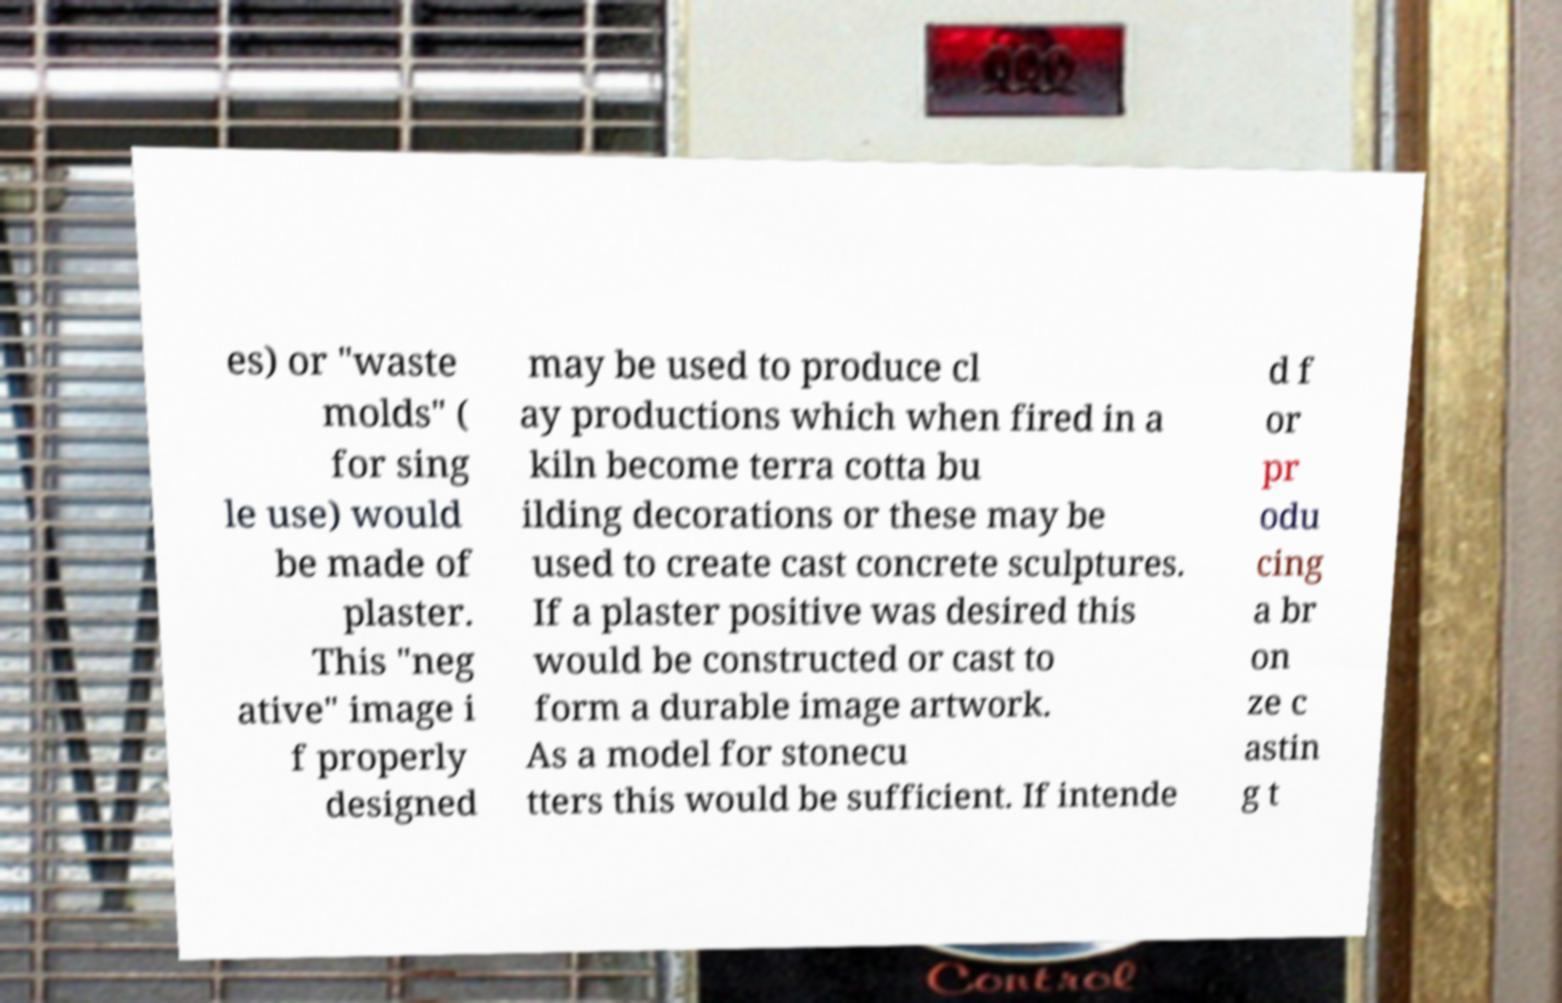What messages or text are displayed in this image? I need them in a readable, typed format. es) or "waste molds" ( for sing le use) would be made of plaster. This "neg ative" image i f properly designed may be used to produce cl ay productions which when fired in a kiln become terra cotta bu ilding decorations or these may be used to create cast concrete sculptures. If a plaster positive was desired this would be constructed or cast to form a durable image artwork. As a model for stonecu tters this would be sufficient. If intende d f or pr odu cing a br on ze c astin g t 